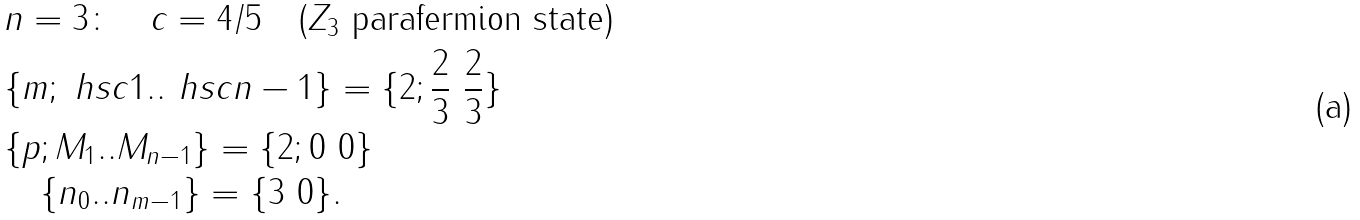<formula> <loc_0><loc_0><loc_500><loc_500>& n = 3 \colon \quad c = 4 / 5 \quad ( Z _ { 3 } \text { parafermion state} ) \\ & \{ m ; \ h s c { 1 } . . \ h s c { n - 1 } \} = \{ 2 ; \frac { 2 } { 3 } \ \frac { 2 } { 3 } \} \\ & \{ p ; M _ { 1 } . . M _ { n - 1 } \} = \{ 2 ; 0 \ 0 \} \\ & \quad \{ n _ { 0 } . . n _ { m - 1 } \} = \{ 3 \ 0 \} .</formula> 